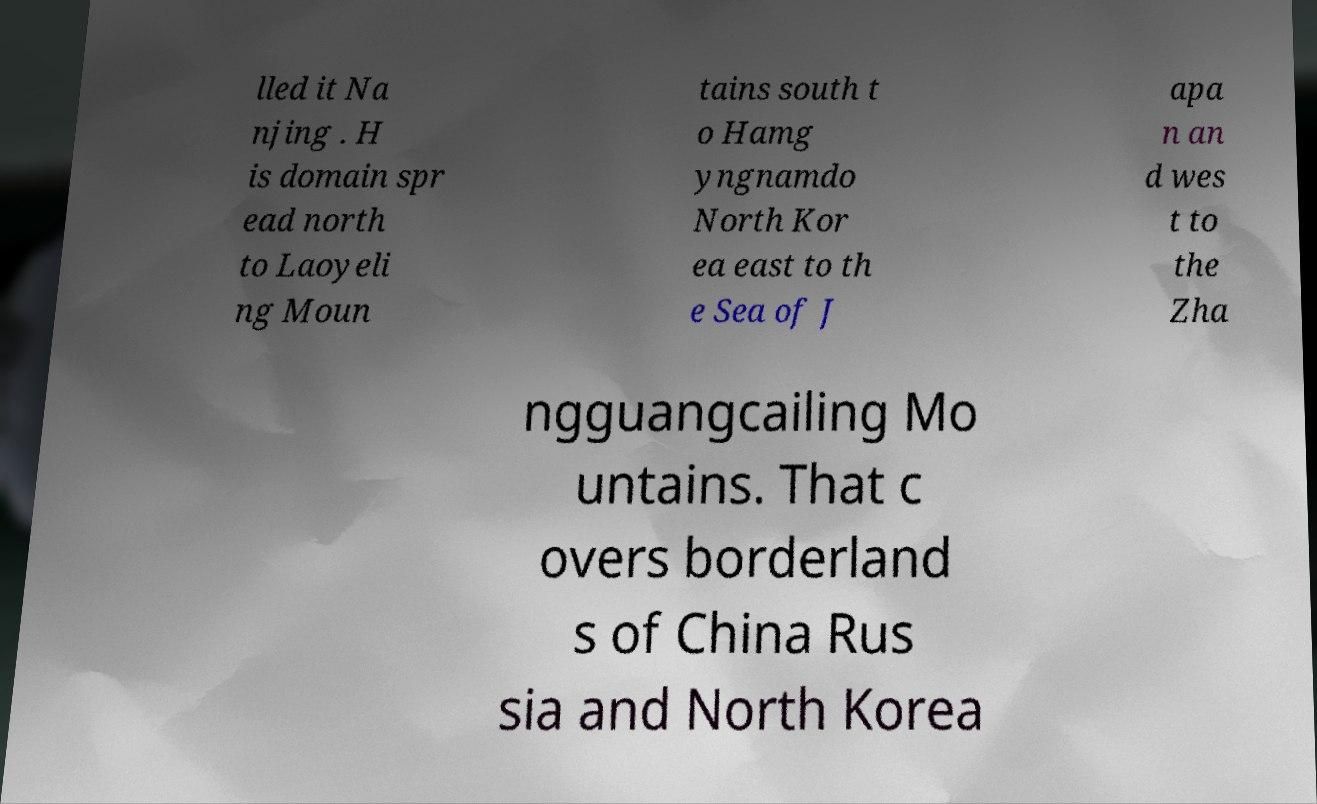Can you read and provide the text displayed in the image?This photo seems to have some interesting text. Can you extract and type it out for me? lled it Na njing . H is domain spr ead north to Laoyeli ng Moun tains south t o Hamg yngnamdo North Kor ea east to th e Sea of J apa n an d wes t to the Zha ngguangcailing Mo untains. That c overs borderland s of China Rus sia and North Korea 